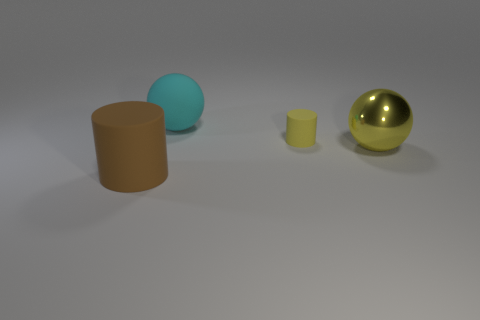Add 3 large yellow cylinders. How many objects exist? 7 Subtract 2 cylinders. How many cylinders are left? 0 Add 2 big cyan objects. How many big cyan objects exist? 3 Subtract 0 purple spheres. How many objects are left? 4 Subtract all yellow cylinders. Subtract all blue spheres. How many cylinders are left? 1 Subtract all brown balls. How many green cylinders are left? 0 Subtract all spheres. Subtract all tiny yellow objects. How many objects are left? 1 Add 3 balls. How many balls are left? 5 